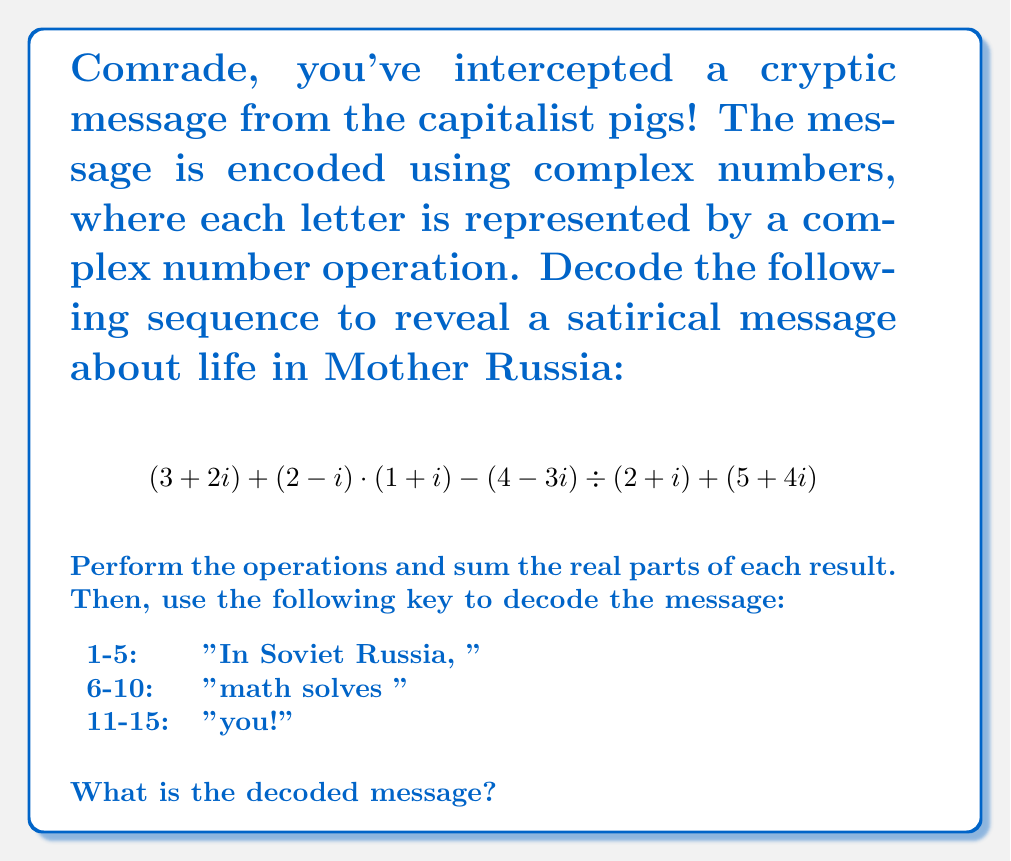Can you solve this math problem? Let's break this down step by step, comrade:

1) First operation: $(3+2i)$
   This is already in its simplest form.

2) Second operation: $(2-i) \cdot (1+i)$
   $$(2-i)(1+i) = 2 + 2i - i - i^2 = 2 + 2i - i + 1 = 3 + i$$

3) Third operation: $(4-3i) \div (2+i)$
   To divide complex numbers, we multiply by the complex conjugate:
   $$\frac{4-3i}{2+i} \cdot \frac{2-i}{2-i} = \frac{(4-3i)(2-i)}{(2+i)(2-i)} = \frac{8-4i-6i+3i^2}{4+1} = \frac{5-10i}{5} = 1-2i$$

4) Fourth operation: $(5+4i)$
   This is already in its simplest form.

Now, let's sum these results:
$$(3+2i) + (3+i) - (1-2i) + (5+4i) = 10+9i$$

The sum of the real parts is 10.

Using the decoding key:
10 falls in the range 6-10, which corresponds to "math solves "
Answer: The decoded message is: "In Soviet Russia, math solves you!" 